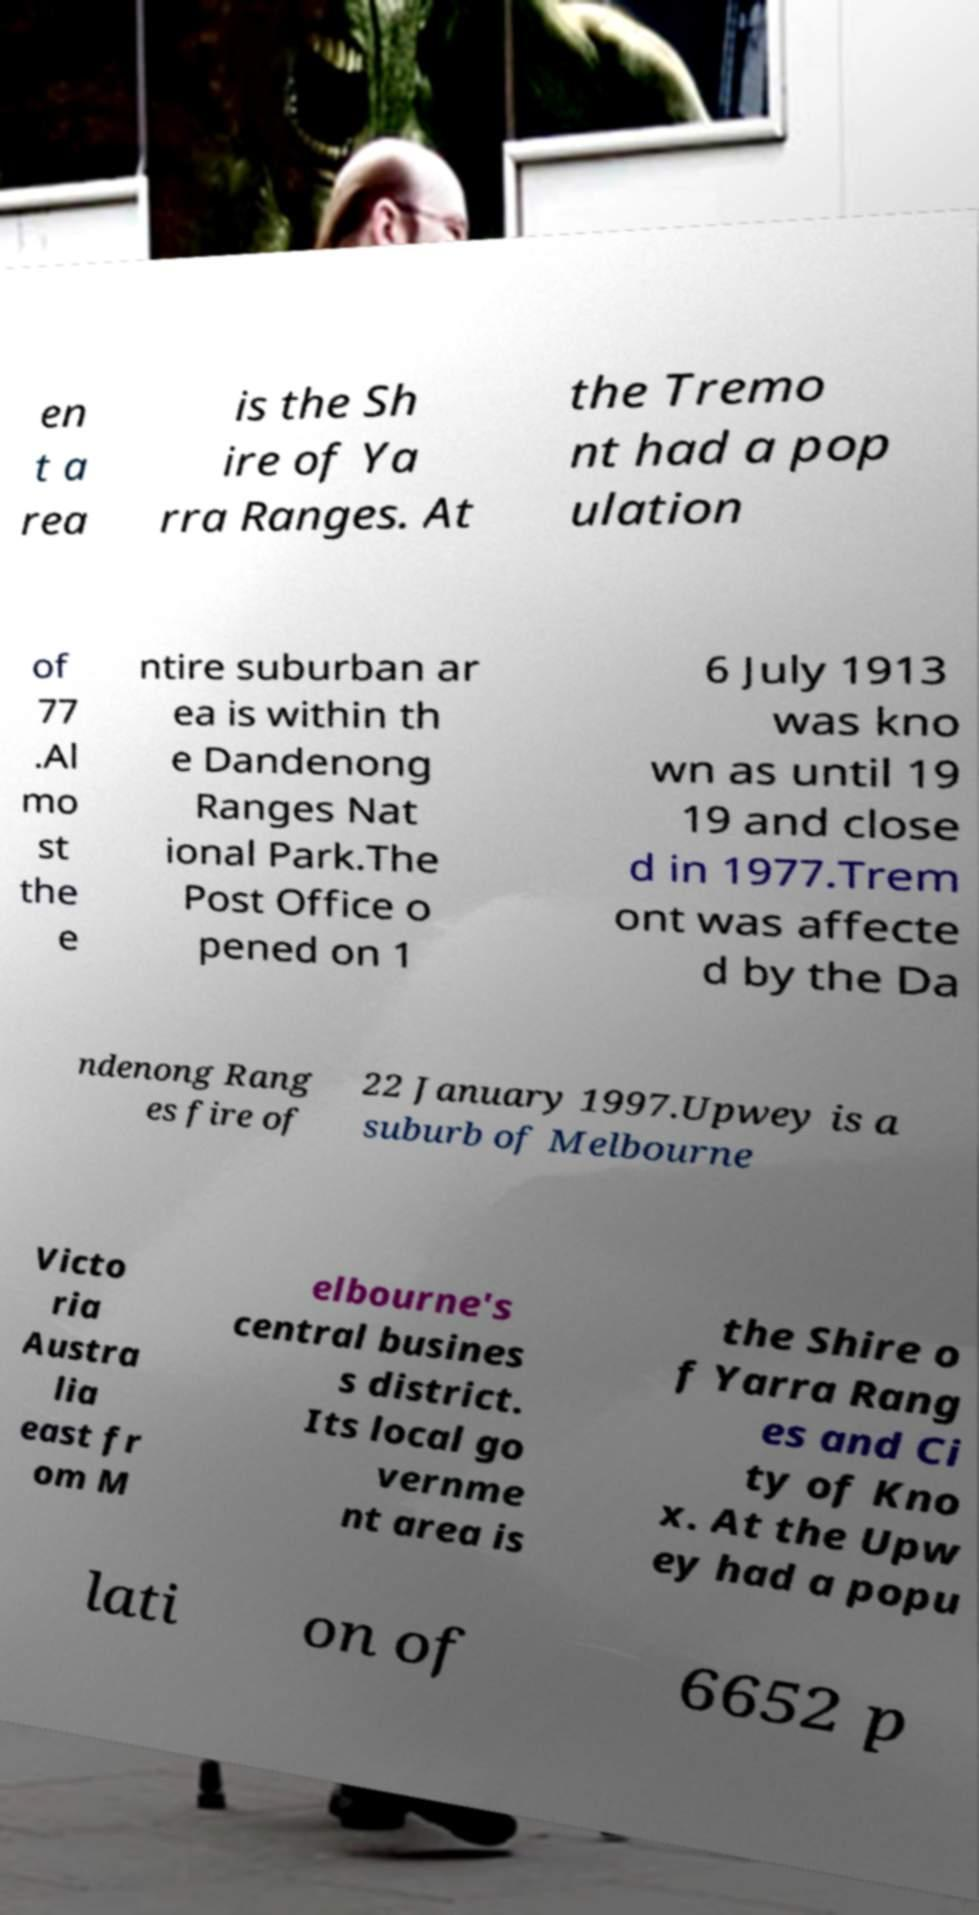Please read and relay the text visible in this image. What does it say? en t a rea is the Sh ire of Ya rra Ranges. At the Tremo nt had a pop ulation of 77 .Al mo st the e ntire suburban ar ea is within th e Dandenong Ranges Nat ional Park.The Post Office o pened on 1 6 July 1913 was kno wn as until 19 19 and close d in 1977.Trem ont was affecte d by the Da ndenong Rang es fire of 22 January 1997.Upwey is a suburb of Melbourne Victo ria Austra lia east fr om M elbourne's central busines s district. Its local go vernme nt area is the Shire o f Yarra Rang es and Ci ty of Kno x. At the Upw ey had a popu lati on of 6652 p 